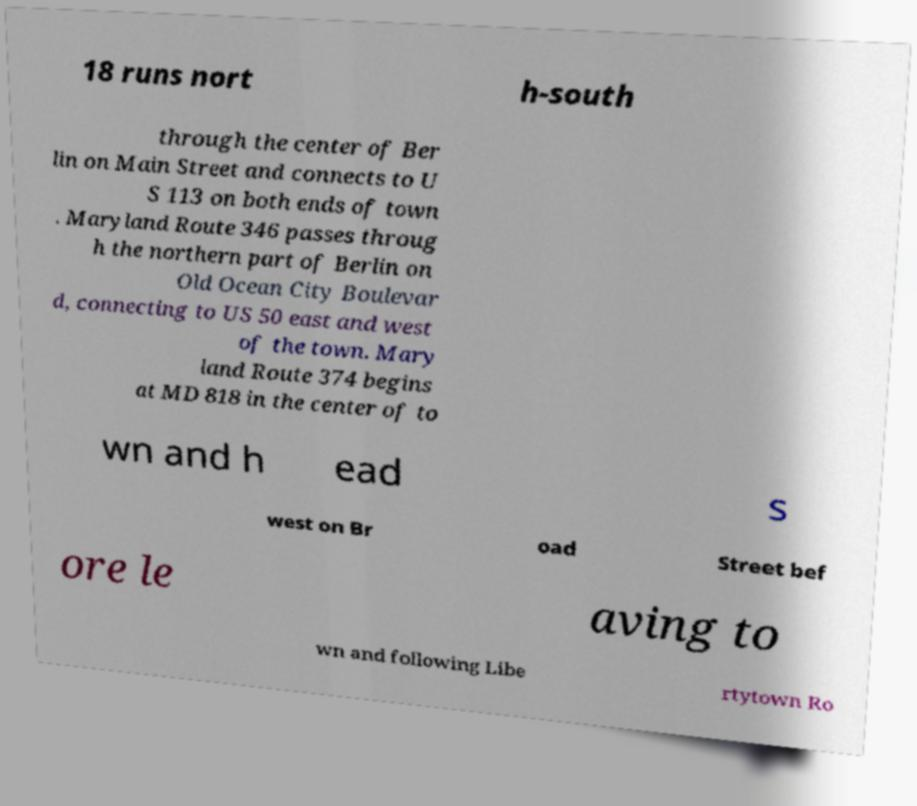Can you read and provide the text displayed in the image?This photo seems to have some interesting text. Can you extract and type it out for me? 18 runs nort h-south through the center of Ber lin on Main Street and connects to U S 113 on both ends of town . Maryland Route 346 passes throug h the northern part of Berlin on Old Ocean City Boulevar d, connecting to US 50 east and west of the town. Mary land Route 374 begins at MD 818 in the center of to wn and h ead s west on Br oad Street bef ore le aving to wn and following Libe rtytown Ro 